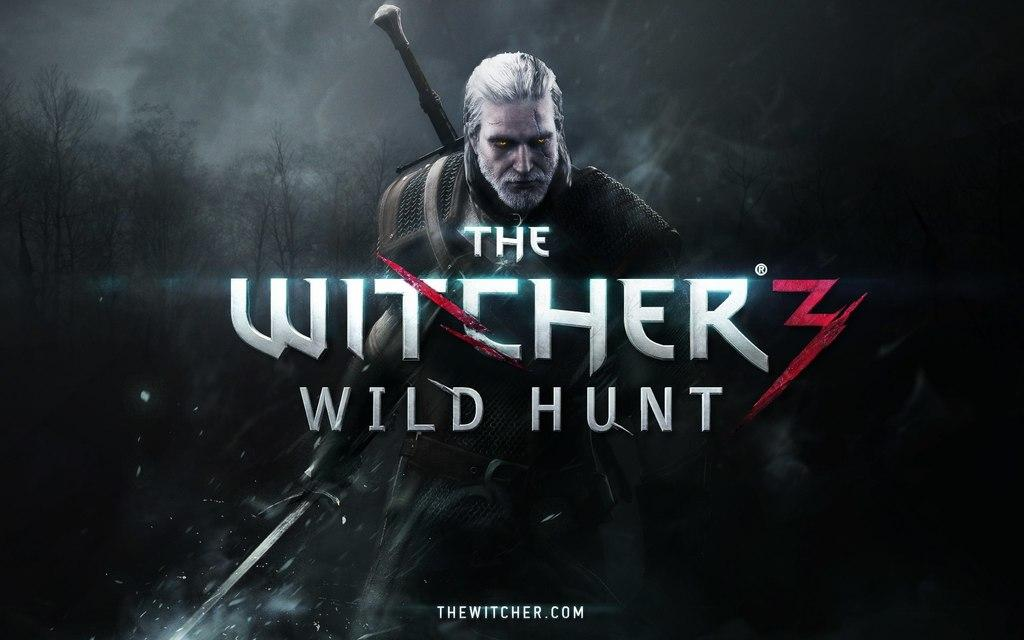Provide a one-sentence caption for the provided image. A poster of ad of a game called The Witcher's wild hunt, it looks frightening. 